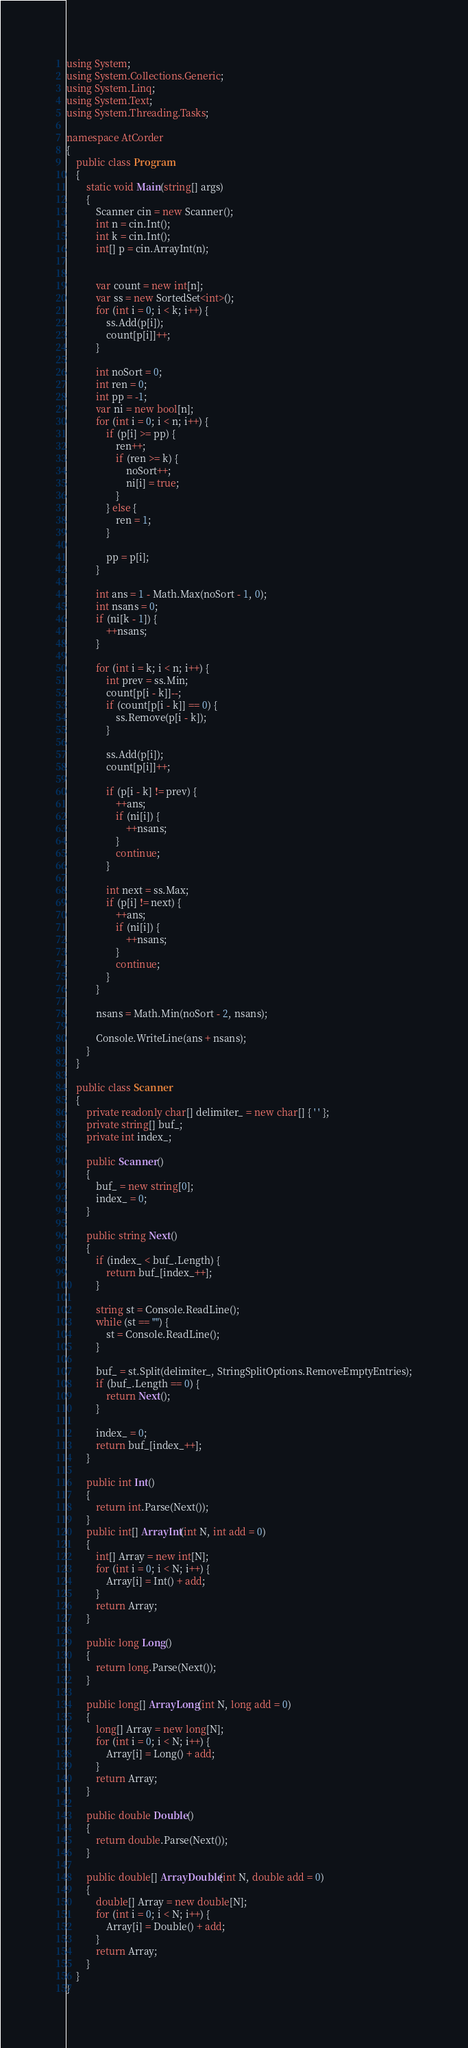Convert code to text. <code><loc_0><loc_0><loc_500><loc_500><_C#_>using System;
using System.Collections.Generic;
using System.Linq;
using System.Text;
using System.Threading.Tasks;

namespace AtCorder
{
	public class Program
	{
		static void Main(string[] args)
		{
			Scanner cin = new Scanner();
			int n = cin.Int();
			int k = cin.Int();
			int[] p = cin.ArrayInt(n);


			var count = new int[n];
			var ss = new SortedSet<int>();
			for (int i = 0; i < k; i++) {
				ss.Add(p[i]);
				count[p[i]]++;
			}

			int noSort = 0;
			int ren = 0;
			int pp = -1;
			var ni = new bool[n];
			for (int i = 0; i < n; i++) {
				if (p[i] >= pp) {
					ren++;
					if (ren >= k) {
						noSort++;
						ni[i] = true;
					}
				} else {
					ren = 1;
				}

				pp = p[i];
			}

			int ans = 1 - Math.Max(noSort - 1, 0);
			int nsans = 0;
			if (ni[k - 1]) {
				++nsans;
			}

			for (int i = k; i < n; i++) {
				int prev = ss.Min;
				count[p[i - k]]--;
				if (count[p[i - k]] == 0) {
					ss.Remove(p[i - k]);
				}

				ss.Add(p[i]);
				count[p[i]]++;

				if (p[i - k] != prev) {
					++ans;
					if (ni[i]) {
						++nsans;
					}
					continue;
				}

				int next = ss.Max;
				if (p[i] != next) {
					++ans;
					if (ni[i]) {
						++nsans;
					}
					continue;
				}
			}

			nsans = Math.Min(noSort - 2, nsans);

			Console.WriteLine(ans + nsans);
		}
	}

	public class Scanner
	{
		private readonly char[] delimiter_ = new char[] { ' ' };
		private string[] buf_;
		private int index_;

		public Scanner()
		{
			buf_ = new string[0];
			index_ = 0;
		}

		public string Next()
		{
			if (index_ < buf_.Length) {
				return buf_[index_++];
			}

			string st = Console.ReadLine();
			while (st == "") {
				st = Console.ReadLine();
			}

			buf_ = st.Split(delimiter_, StringSplitOptions.RemoveEmptyEntries);
			if (buf_.Length == 0) {
				return Next();
			}

			index_ = 0;
			return buf_[index_++];
		}

		public int Int()
		{
			return int.Parse(Next());
		}
		public int[] ArrayInt(int N, int add = 0)
		{
			int[] Array = new int[N];
			for (int i = 0; i < N; i++) {
				Array[i] = Int() + add;
			}
			return Array;
		}

		public long Long()
		{
			return long.Parse(Next());
		}

		public long[] ArrayLong(int N, long add = 0)
		{
			long[] Array = new long[N];
			for (int i = 0; i < N; i++) {
				Array[i] = Long() + add;
			}
			return Array;
		}

		public double Double()
		{
			return double.Parse(Next());
		}

		public double[] ArrayDouble(int N, double add = 0)
		{
			double[] Array = new double[N];
			for (int i = 0; i < N; i++) {
				Array[i] = Double() + add;
			}
			return Array;
		}
	}
}</code> 